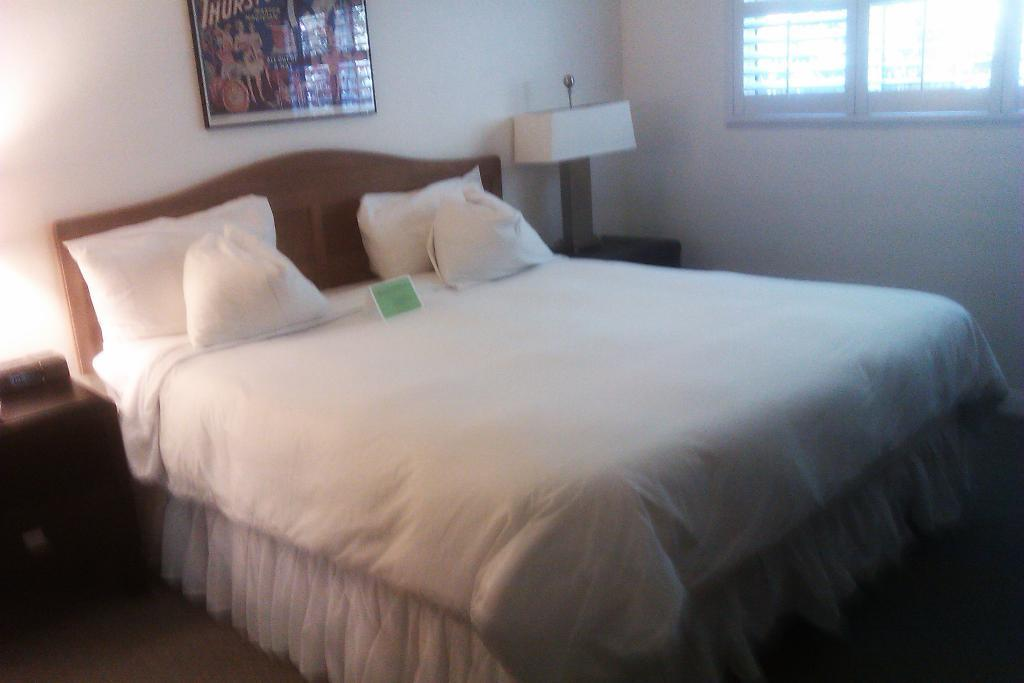What piece of furniture is present in the image? There is a bed in the image. What is placed on the bed? There are pillows on the bed. What type of object can be seen in the image that provides support or structure? There is a frame in the image. What source of light is visible in the image? There is a lamp in the image. What allows natural light to enter the room in the image? There is a window in the image. What surface is visible beneath the bed in the image? There is a floor visible in the image. What type of rabbit can be seen hopping on the bed in the image? There is no rabbit present in the image; it only features a bed, pillows, a frame, a lamp, a window, and a floor. How does the person in the image feel about the temperature in the room? There is no person present in the image, so it is impossible to determine their feelings about the temperature in the room. 